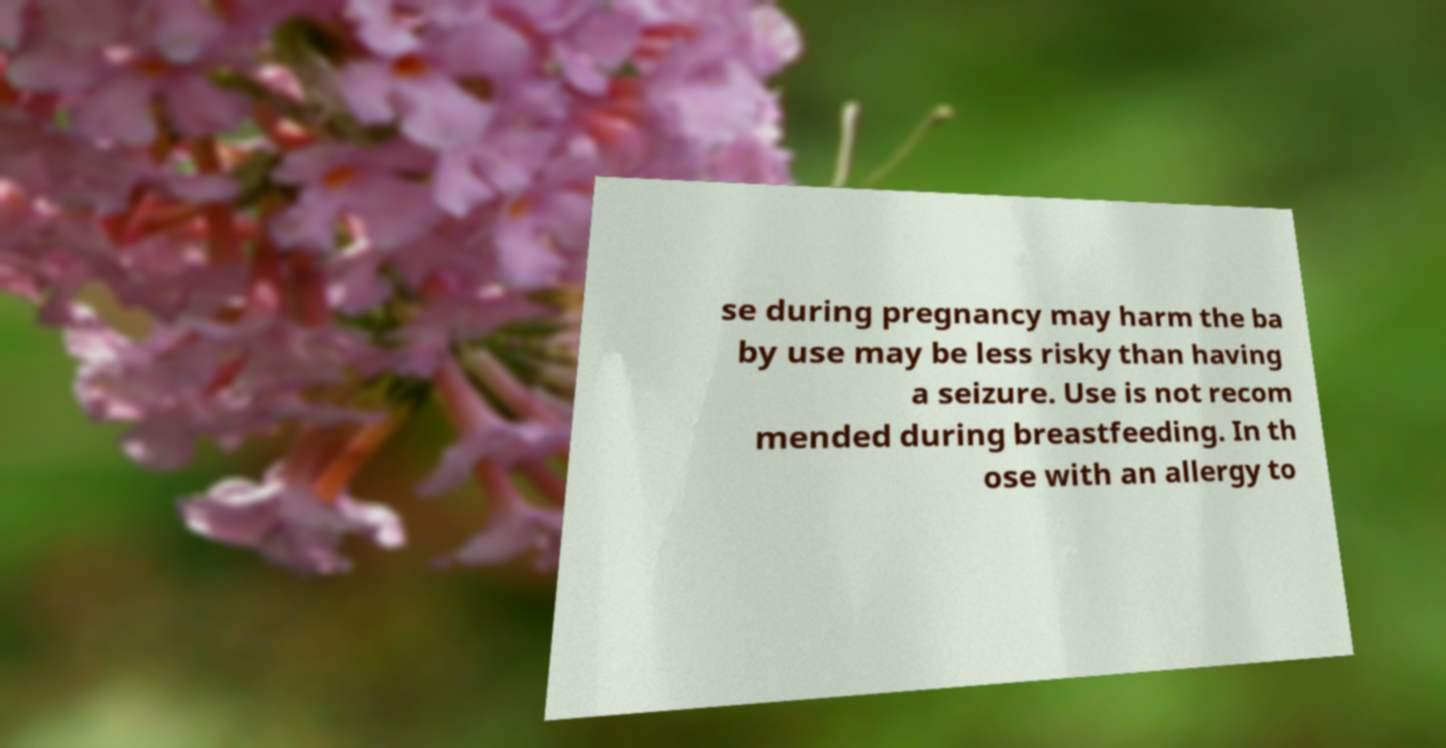There's text embedded in this image that I need extracted. Can you transcribe it verbatim? se during pregnancy may harm the ba by use may be less risky than having a seizure. Use is not recom mended during breastfeeding. In th ose with an allergy to 